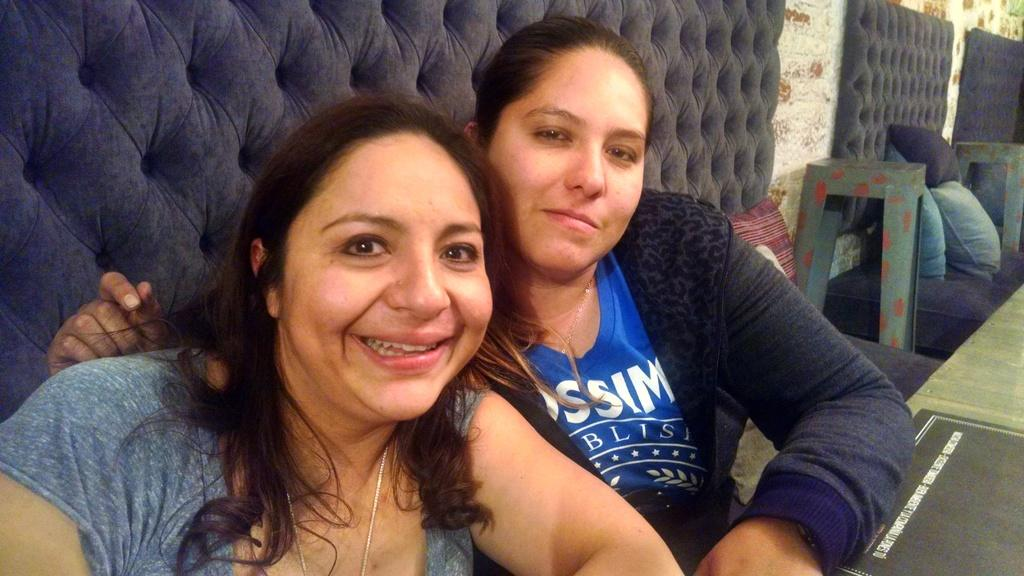How many people are in the image? There are two women in the image. What are the women doing in the image? The women are sitting in front of a table. What can be seen in the background of the image? There is a wall in the background of the image. What type of authority do the women have in the image? There is no indication of any authority in the image, as it only shows two women sitting in front of a table. Can you see any badges on the women in the image? There are no badges visible on the women in the image. 